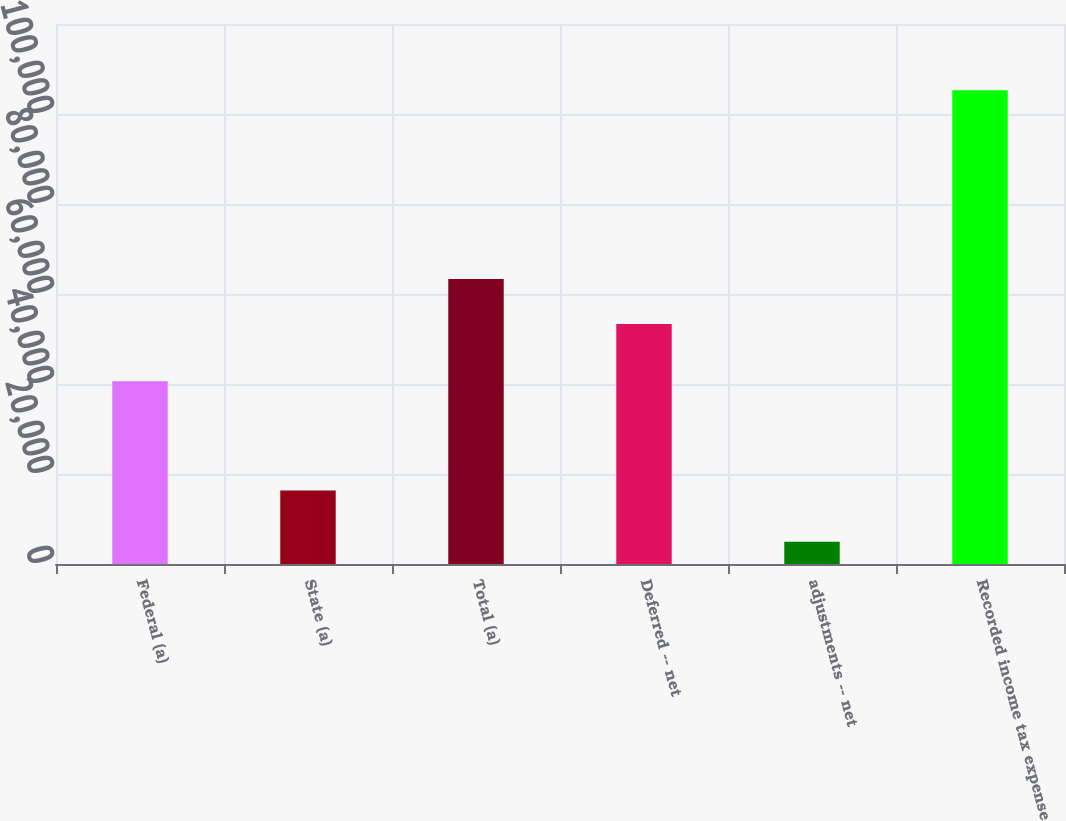<chart> <loc_0><loc_0><loc_500><loc_500><bar_chart><fcel>Federal (a)<fcel>State (a)<fcel>Total (a)<fcel>Deferred -- net<fcel>adjustments -- net<fcel>Recorded income tax expense<nl><fcel>40632<fcel>16306<fcel>63343.5<fcel>53309<fcel>4951<fcel>105296<nl></chart> 